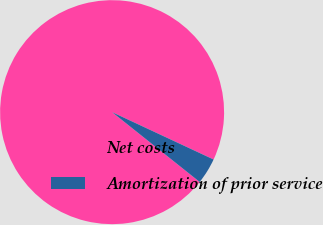Convert chart. <chart><loc_0><loc_0><loc_500><loc_500><pie_chart><fcel>Net costs<fcel>Amortization of prior service<nl><fcel>96.24%<fcel>3.76%<nl></chart> 